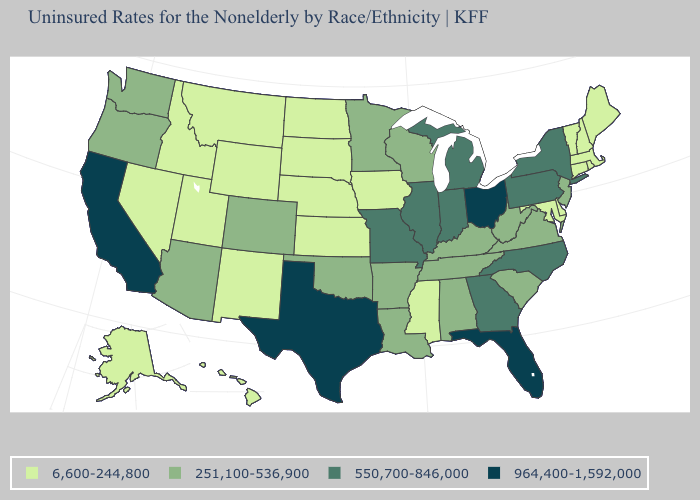Does Wyoming have the lowest value in the USA?
Concise answer only. Yes. Which states hav the highest value in the South?
Keep it brief. Florida, Texas. How many symbols are there in the legend?
Write a very short answer. 4. What is the value of New York?
Short answer required. 550,700-846,000. What is the value of Maine?
Write a very short answer. 6,600-244,800. What is the value of Nevada?
Answer briefly. 6,600-244,800. Does Delaware have the lowest value in the South?
Give a very brief answer. Yes. How many symbols are there in the legend?
Concise answer only. 4. Name the states that have a value in the range 550,700-846,000?
Quick response, please. Georgia, Illinois, Indiana, Michigan, Missouri, New York, North Carolina, Pennsylvania. Name the states that have a value in the range 251,100-536,900?
Write a very short answer. Alabama, Arizona, Arkansas, Colorado, Kentucky, Louisiana, Minnesota, New Jersey, Oklahoma, Oregon, South Carolina, Tennessee, Virginia, Washington, West Virginia, Wisconsin. What is the value of North Dakota?
Quick response, please. 6,600-244,800. Which states hav the highest value in the MidWest?
Be succinct. Ohio. Does Illinois have the same value as Michigan?
Short answer required. Yes. What is the lowest value in states that border Louisiana?
Be succinct. 6,600-244,800. Does Iowa have the lowest value in the MidWest?
Concise answer only. Yes. 